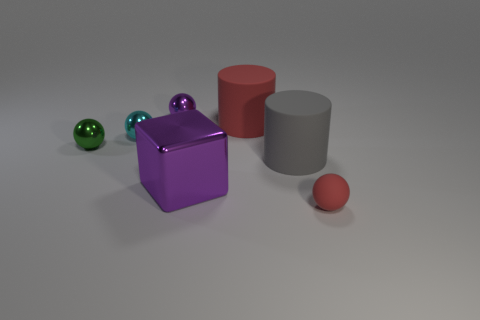Subtract all cyan balls. How many balls are left? 3 Subtract all green spheres. How many spheres are left? 3 Subtract 1 cylinders. How many cylinders are left? 1 Add 3 big purple blocks. How many objects exist? 10 Add 4 green objects. How many green objects are left? 5 Add 6 tiny things. How many tiny things exist? 10 Subtract 0 blue cylinders. How many objects are left? 7 Subtract all spheres. How many objects are left? 3 Subtract all red cylinders. Subtract all red spheres. How many cylinders are left? 1 Subtract all brown blocks. How many green spheres are left? 1 